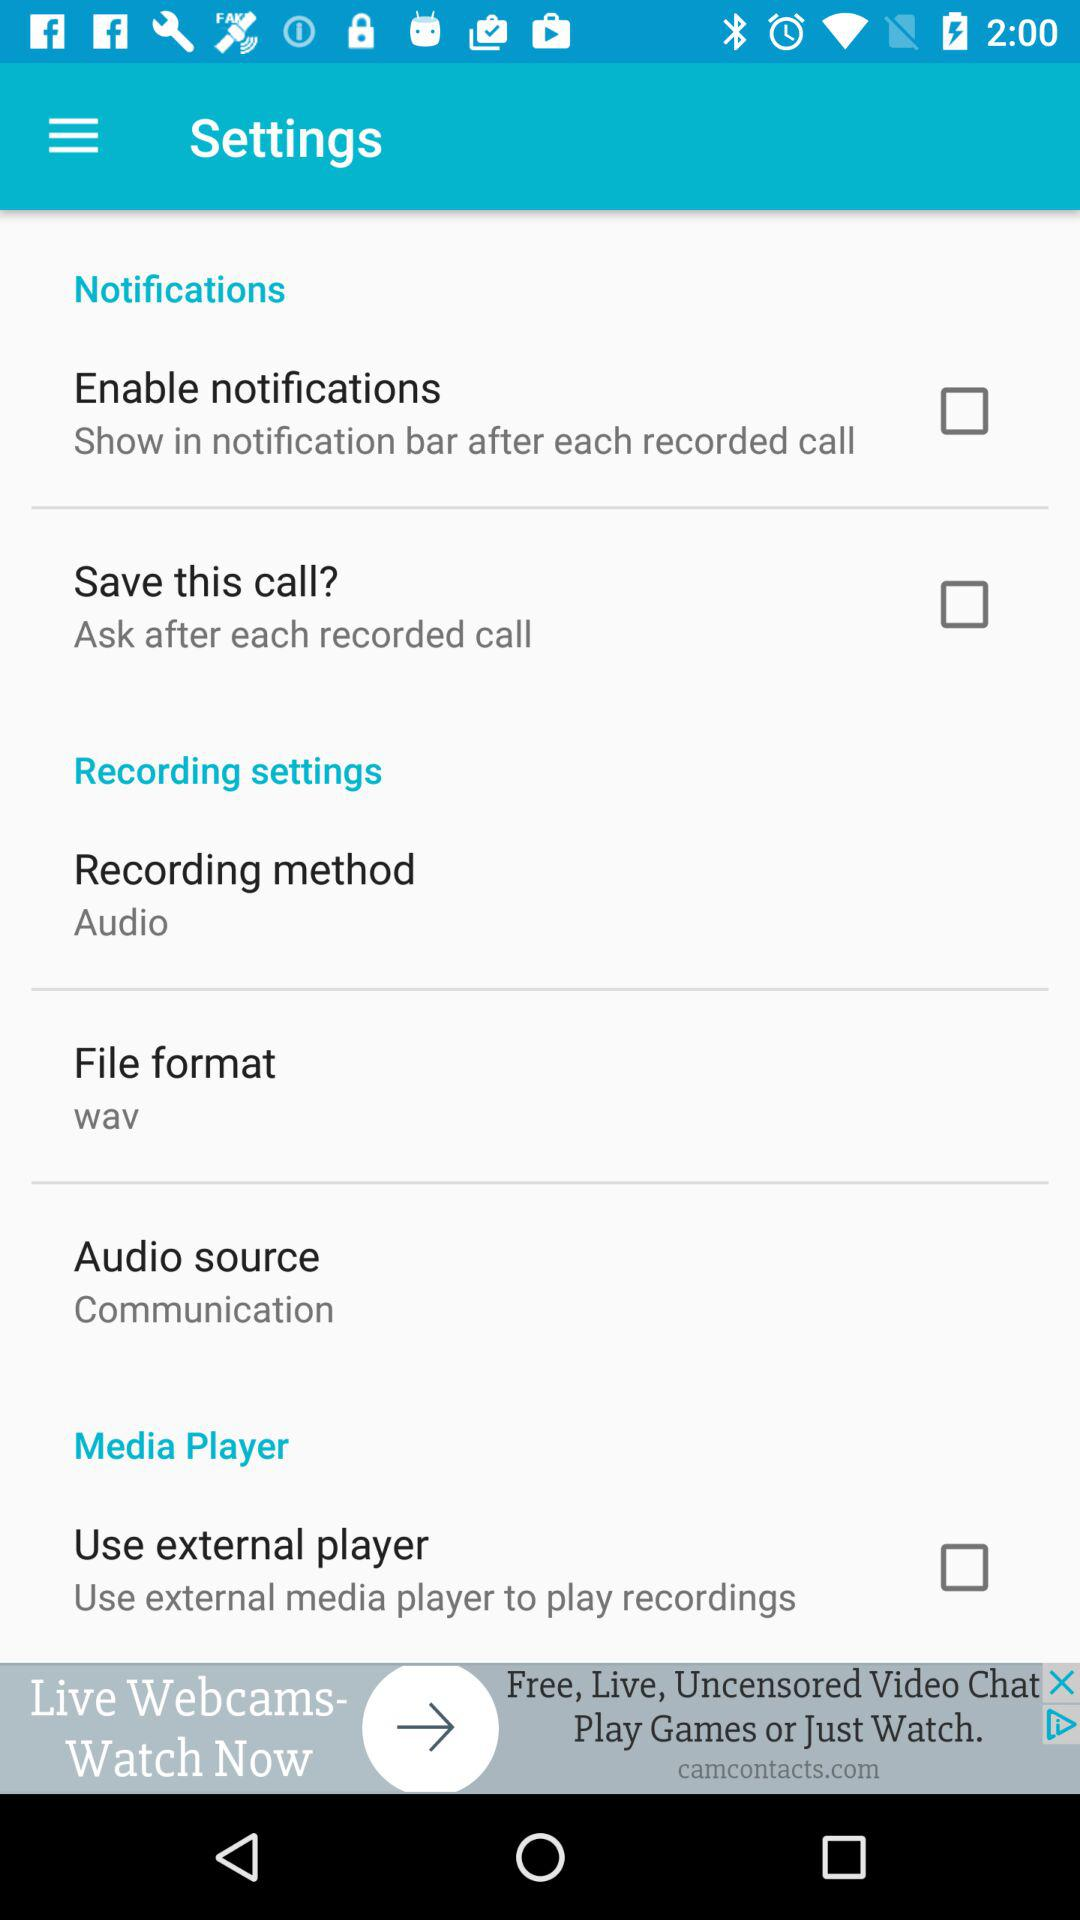What is the status of "Save this call?"? The status is "off". 